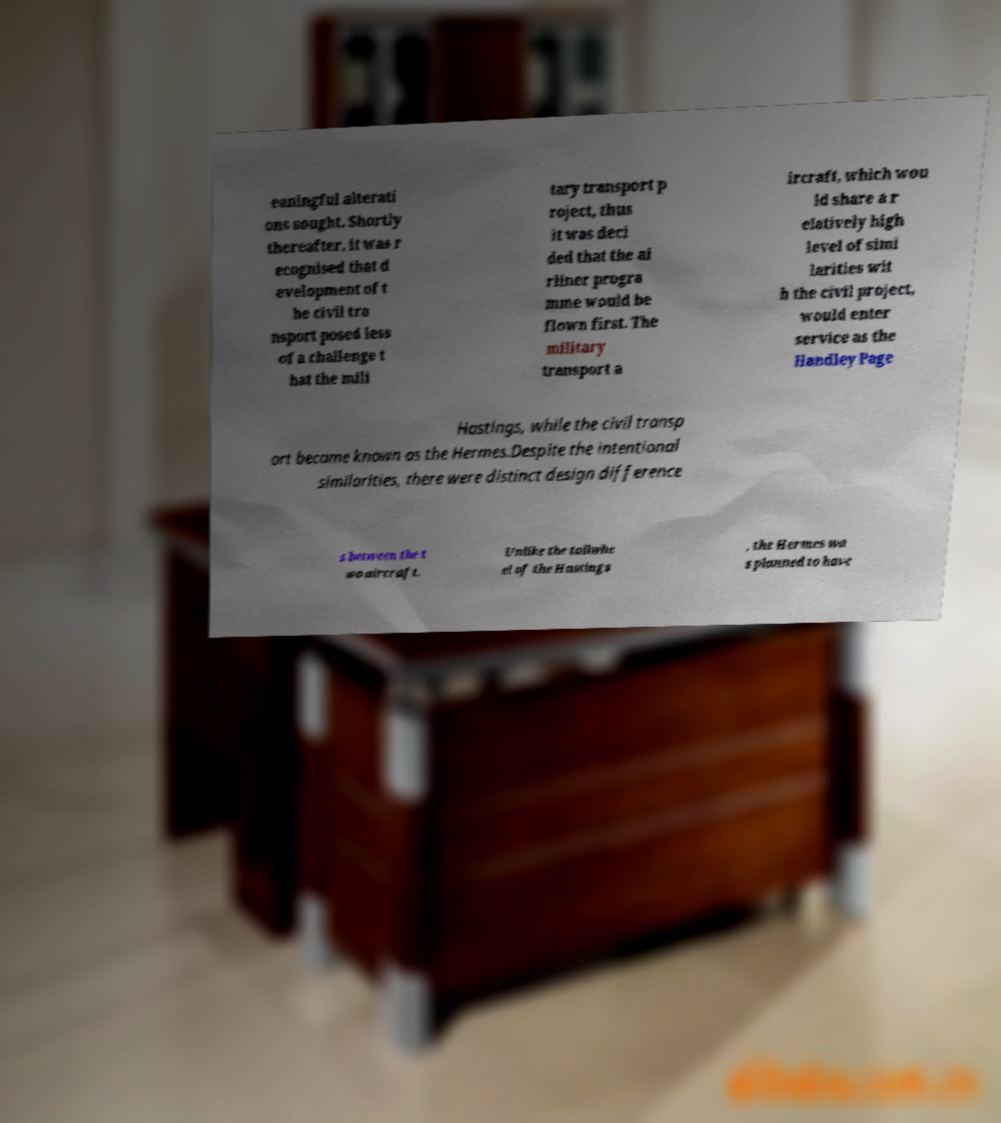There's text embedded in this image that I need extracted. Can you transcribe it verbatim? eaningful alterati ons sought. Shortly thereafter, it was r ecognised that d evelopment of t he civil tra nsport posed less of a challenge t hat the mili tary transport p roject, thus it was deci ded that the ai rliner progra mme would be flown first. The military transport a ircraft, which wou ld share a r elatively high level of simi larities wit h the civil project, would enter service as the Handley Page Hastings, while the civil transp ort became known as the Hermes.Despite the intentional similarities, there were distinct design difference s between the t wo aircraft. Unlike the tailwhe el of the Hastings , the Hermes wa s planned to have 